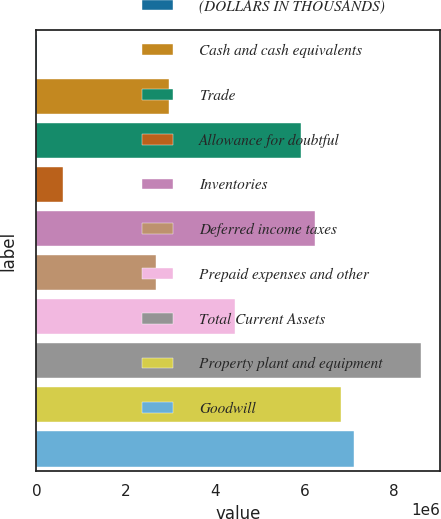<chart> <loc_0><loc_0><loc_500><loc_500><bar_chart><fcel>(DOLLARS IN THOUSANDS)<fcel>Cash and cash equivalents<fcel>Trade<fcel>Allowance for doubtful<fcel>Inventories<fcel>Deferred income taxes<fcel>Prepaid expenses and other<fcel>Total Current Assets<fcel>Property plant and equipment<fcel>Goodwill<nl><fcel>2011<fcel>2.96558e+06<fcel>5.92915e+06<fcel>594725<fcel>6.22551e+06<fcel>2.66922e+06<fcel>4.44737e+06<fcel>8.59636e+06<fcel>6.81822e+06<fcel>7.11458e+06<nl></chart> 